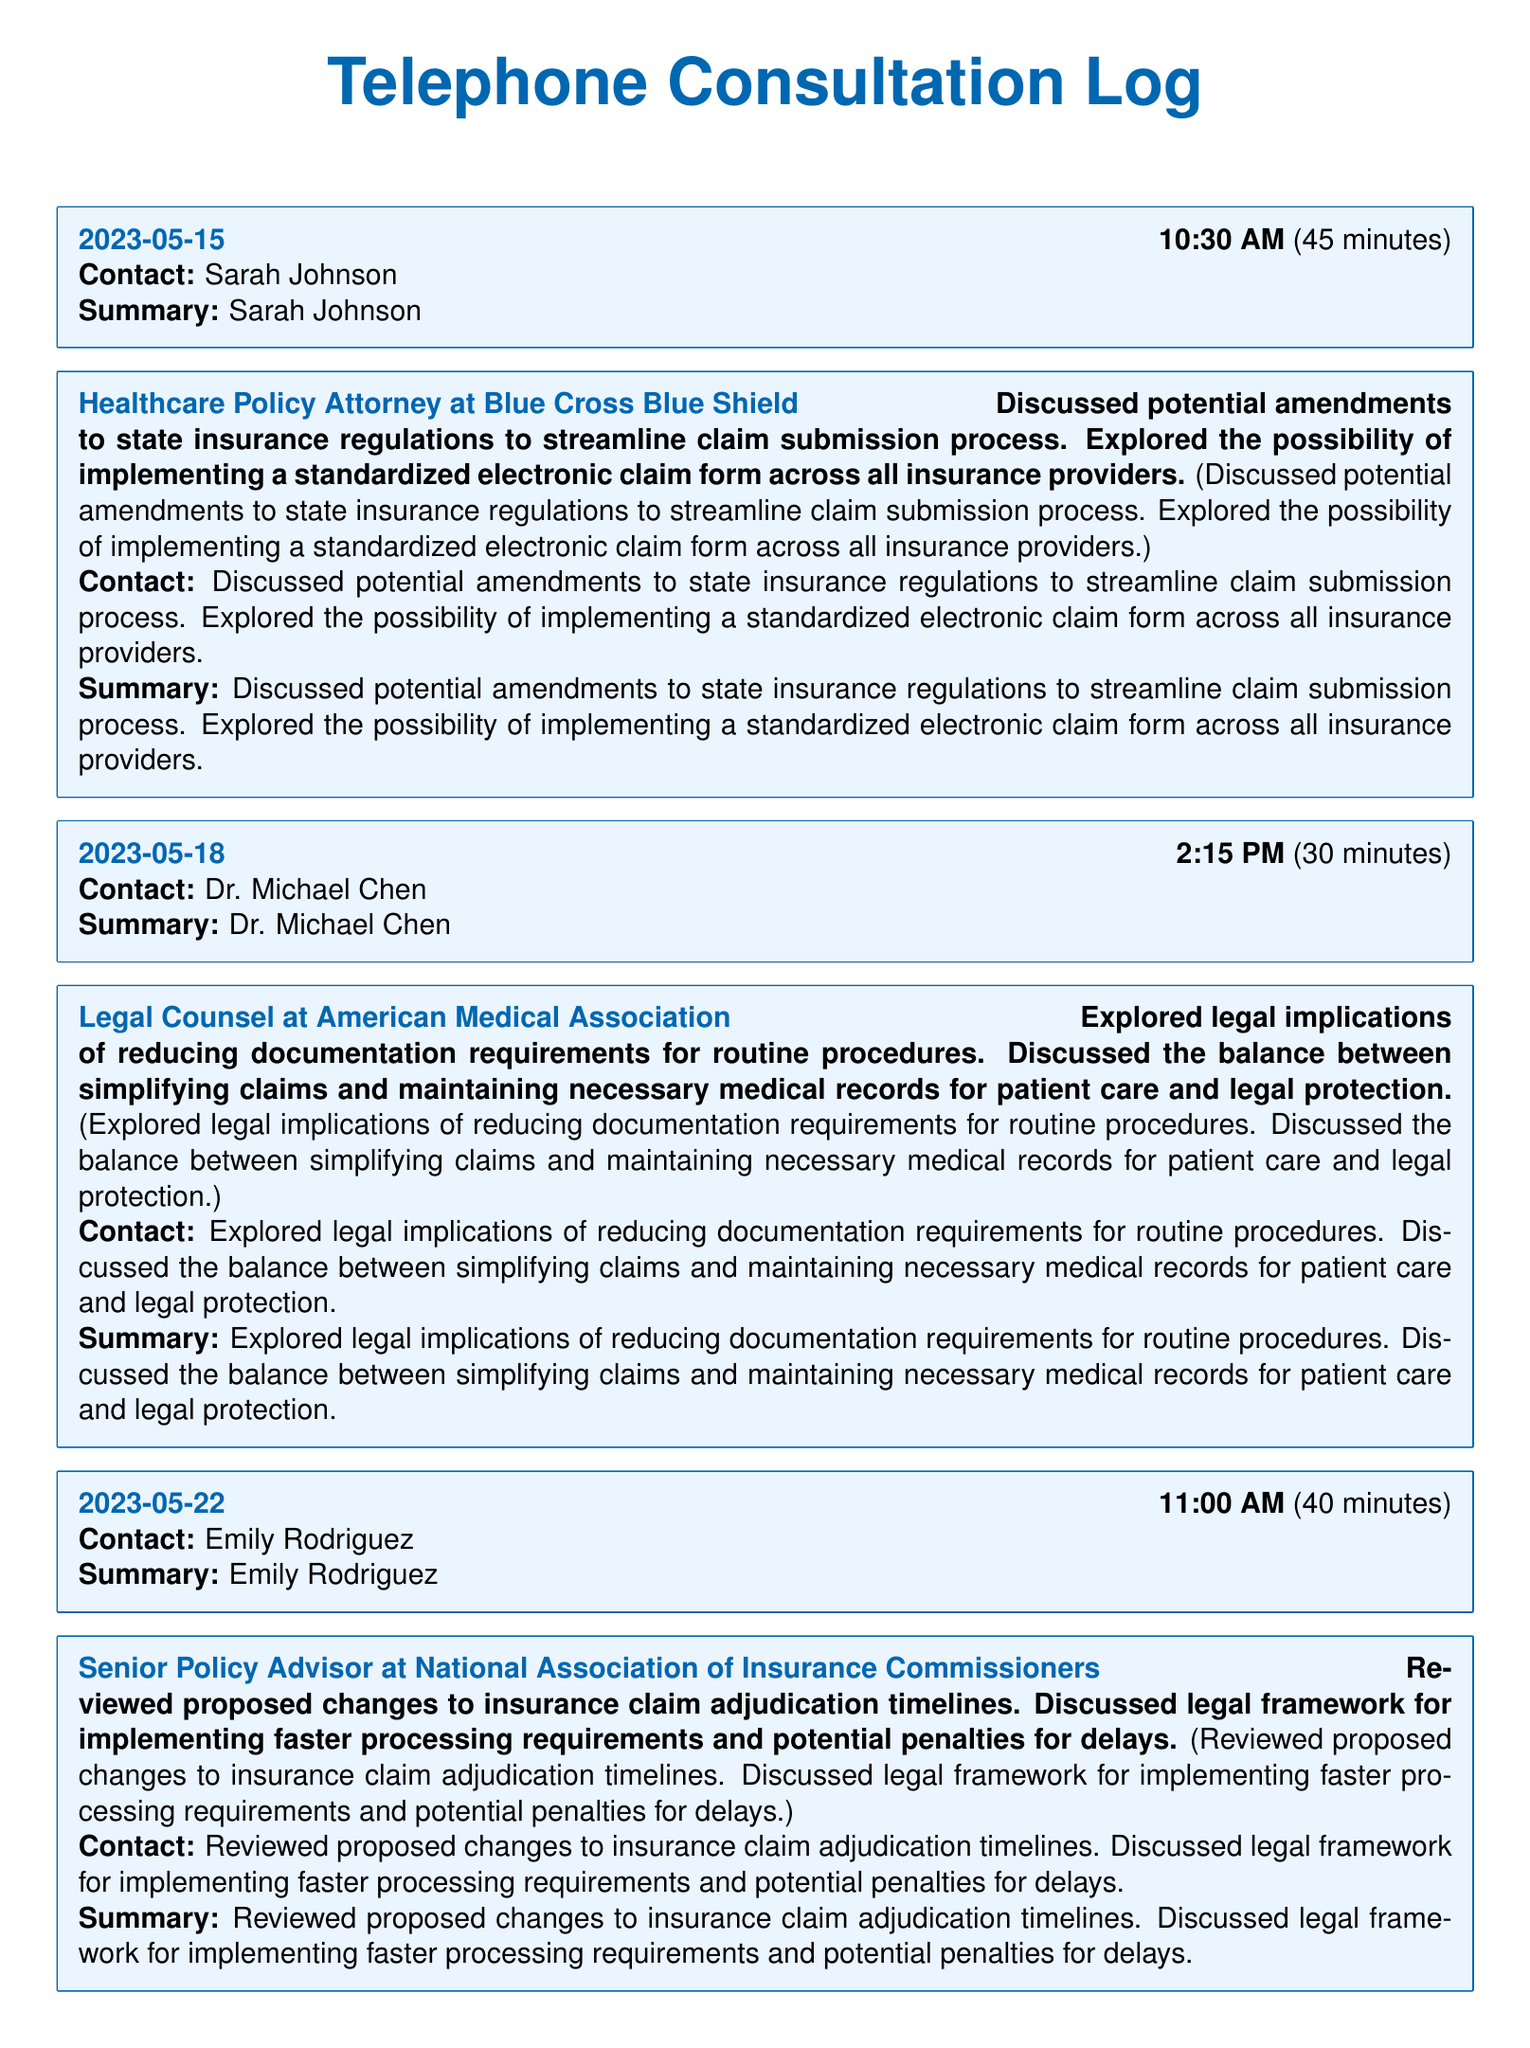What is the date of the consultation with Sarah Johnson? The consultation with Sarah Johnson took place on May 15, 2023.
Answer: May 15, 2023 How long did the consultation with Dr. Michael Chen last? The consultation with Dr. Michael Chen lasted 30 minutes.
Answer: 30 minutes Who is the contact for the May 30 consultation? The contact for the May 30 consultation is Lisa Patel.
Answer: Lisa Patel What topic was discussed during the consultation with Robert Thompson? The consultation with Robert Thompson explored AI-assisted claim processing.
Answer: AI-assisted claim processing What is one potential benefit discussed in the consultation with Emily Rodriguez? The consultation with Emily Rodriguez discussed implementing faster processing requirements for insurance claims.
Answer: Faster processing requirements How many minutes did the longest consultation last? The longest consultation lasted for 50 minutes.
Answer: 50 minutes What is the main focus of the consultations recorded in this log? The main focus is to simplify the insurance claim procedures.
Answer: Simplify insurance claim procedures Which attorney is associated with Blue Cross Blue Shield? Sarah Johnson is the attorney associated with Blue Cross Blue Shield.
Answer: Sarah Johnson What was the main legal concern discussed with Lisa Patel? The main legal concern was the creation of a unified appeals process.
Answer: Unified appeals process 